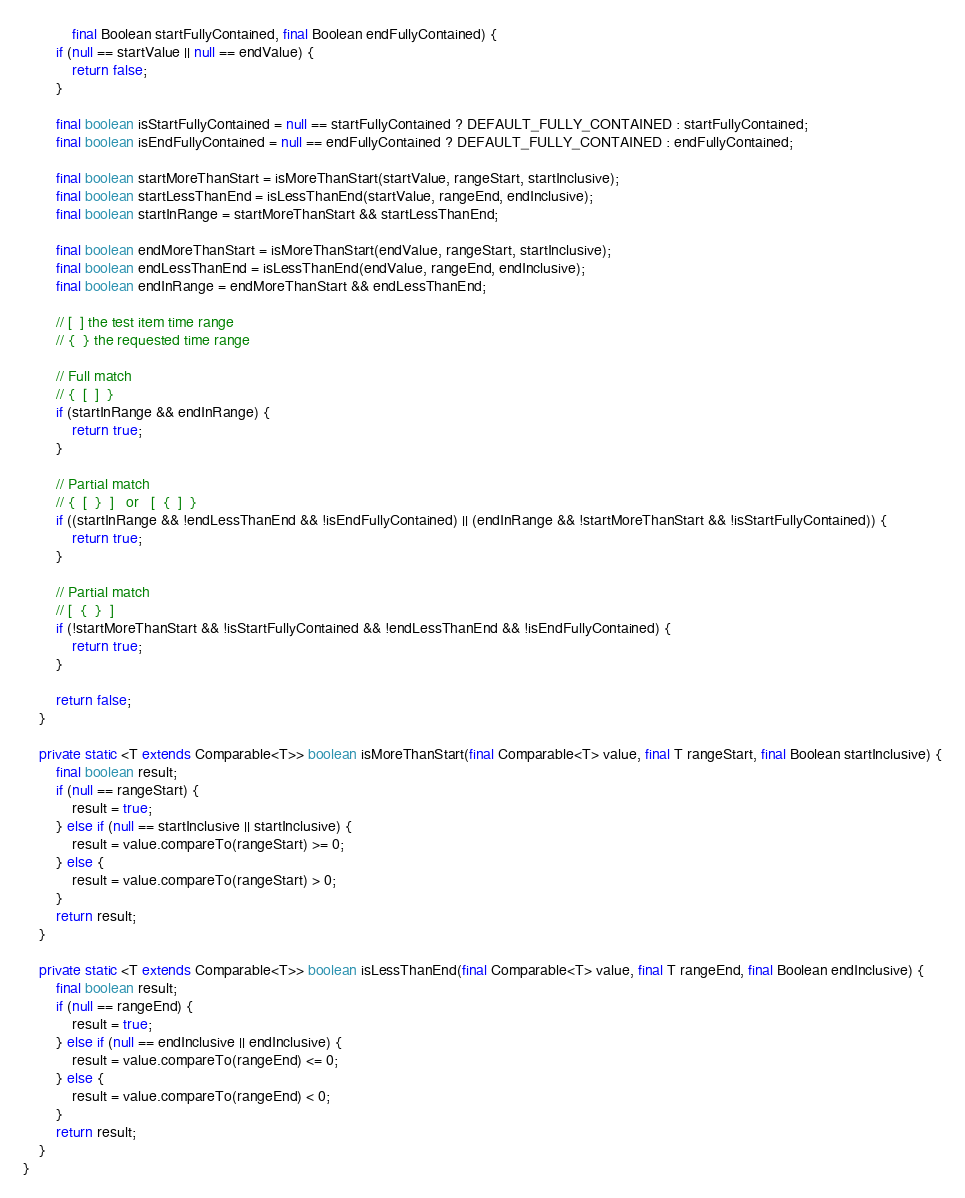Convert code to text. <code><loc_0><loc_0><loc_500><loc_500><_Java_>            final Boolean startFullyContained, final Boolean endFullyContained) {
        if (null == startValue || null == endValue) {
            return false;
        }

        final boolean isStartFullyContained = null == startFullyContained ? DEFAULT_FULLY_CONTAINED : startFullyContained;
        final boolean isEndFullyContained = null == endFullyContained ? DEFAULT_FULLY_CONTAINED : endFullyContained;

        final boolean startMoreThanStart = isMoreThanStart(startValue, rangeStart, startInclusive);
        final boolean startLessThanEnd = isLessThanEnd(startValue, rangeEnd, endInclusive);
        final boolean startInRange = startMoreThanStart && startLessThanEnd;

        final boolean endMoreThanStart = isMoreThanStart(endValue, rangeStart, startInclusive);
        final boolean endLessThanEnd = isLessThanEnd(endValue, rangeEnd, endInclusive);
        final boolean endInRange = endMoreThanStart && endLessThanEnd;

        // [  ] the test item time range
        // {  } the requested time range

        // Full match
        // {  [  ]  }
        if (startInRange && endInRange) {
            return true;
        }

        // Partial match
        // {  [  }  ]   or   [  {  ]  }
        if ((startInRange && !endLessThanEnd && !isEndFullyContained) || (endInRange && !startMoreThanStart && !isStartFullyContained)) {
            return true;
        }

        // Partial match
        // [  {  }  ]
        if (!startMoreThanStart && !isStartFullyContained && !endLessThanEnd && !isEndFullyContained) {
            return true;
        }

        return false;
    }

    private static <T extends Comparable<T>> boolean isMoreThanStart(final Comparable<T> value, final T rangeStart, final Boolean startInclusive) {
        final boolean result;
        if (null == rangeStart) {
            result = true;
        } else if (null == startInclusive || startInclusive) {
            result = value.compareTo(rangeStart) >= 0;
        } else {
            result = value.compareTo(rangeStart) > 0;
        }
        return result;
    }

    private static <T extends Comparable<T>> boolean isLessThanEnd(final Comparable<T> value, final T rangeEnd, final Boolean endInclusive) {
        final boolean result;
        if (null == rangeEnd) {
            result = true;
        } else if (null == endInclusive || endInclusive) {
            result = value.compareTo(rangeEnd) <= 0;
        } else {
            result = value.compareTo(rangeEnd) < 0;
        }
        return result;
    }
}
</code> 